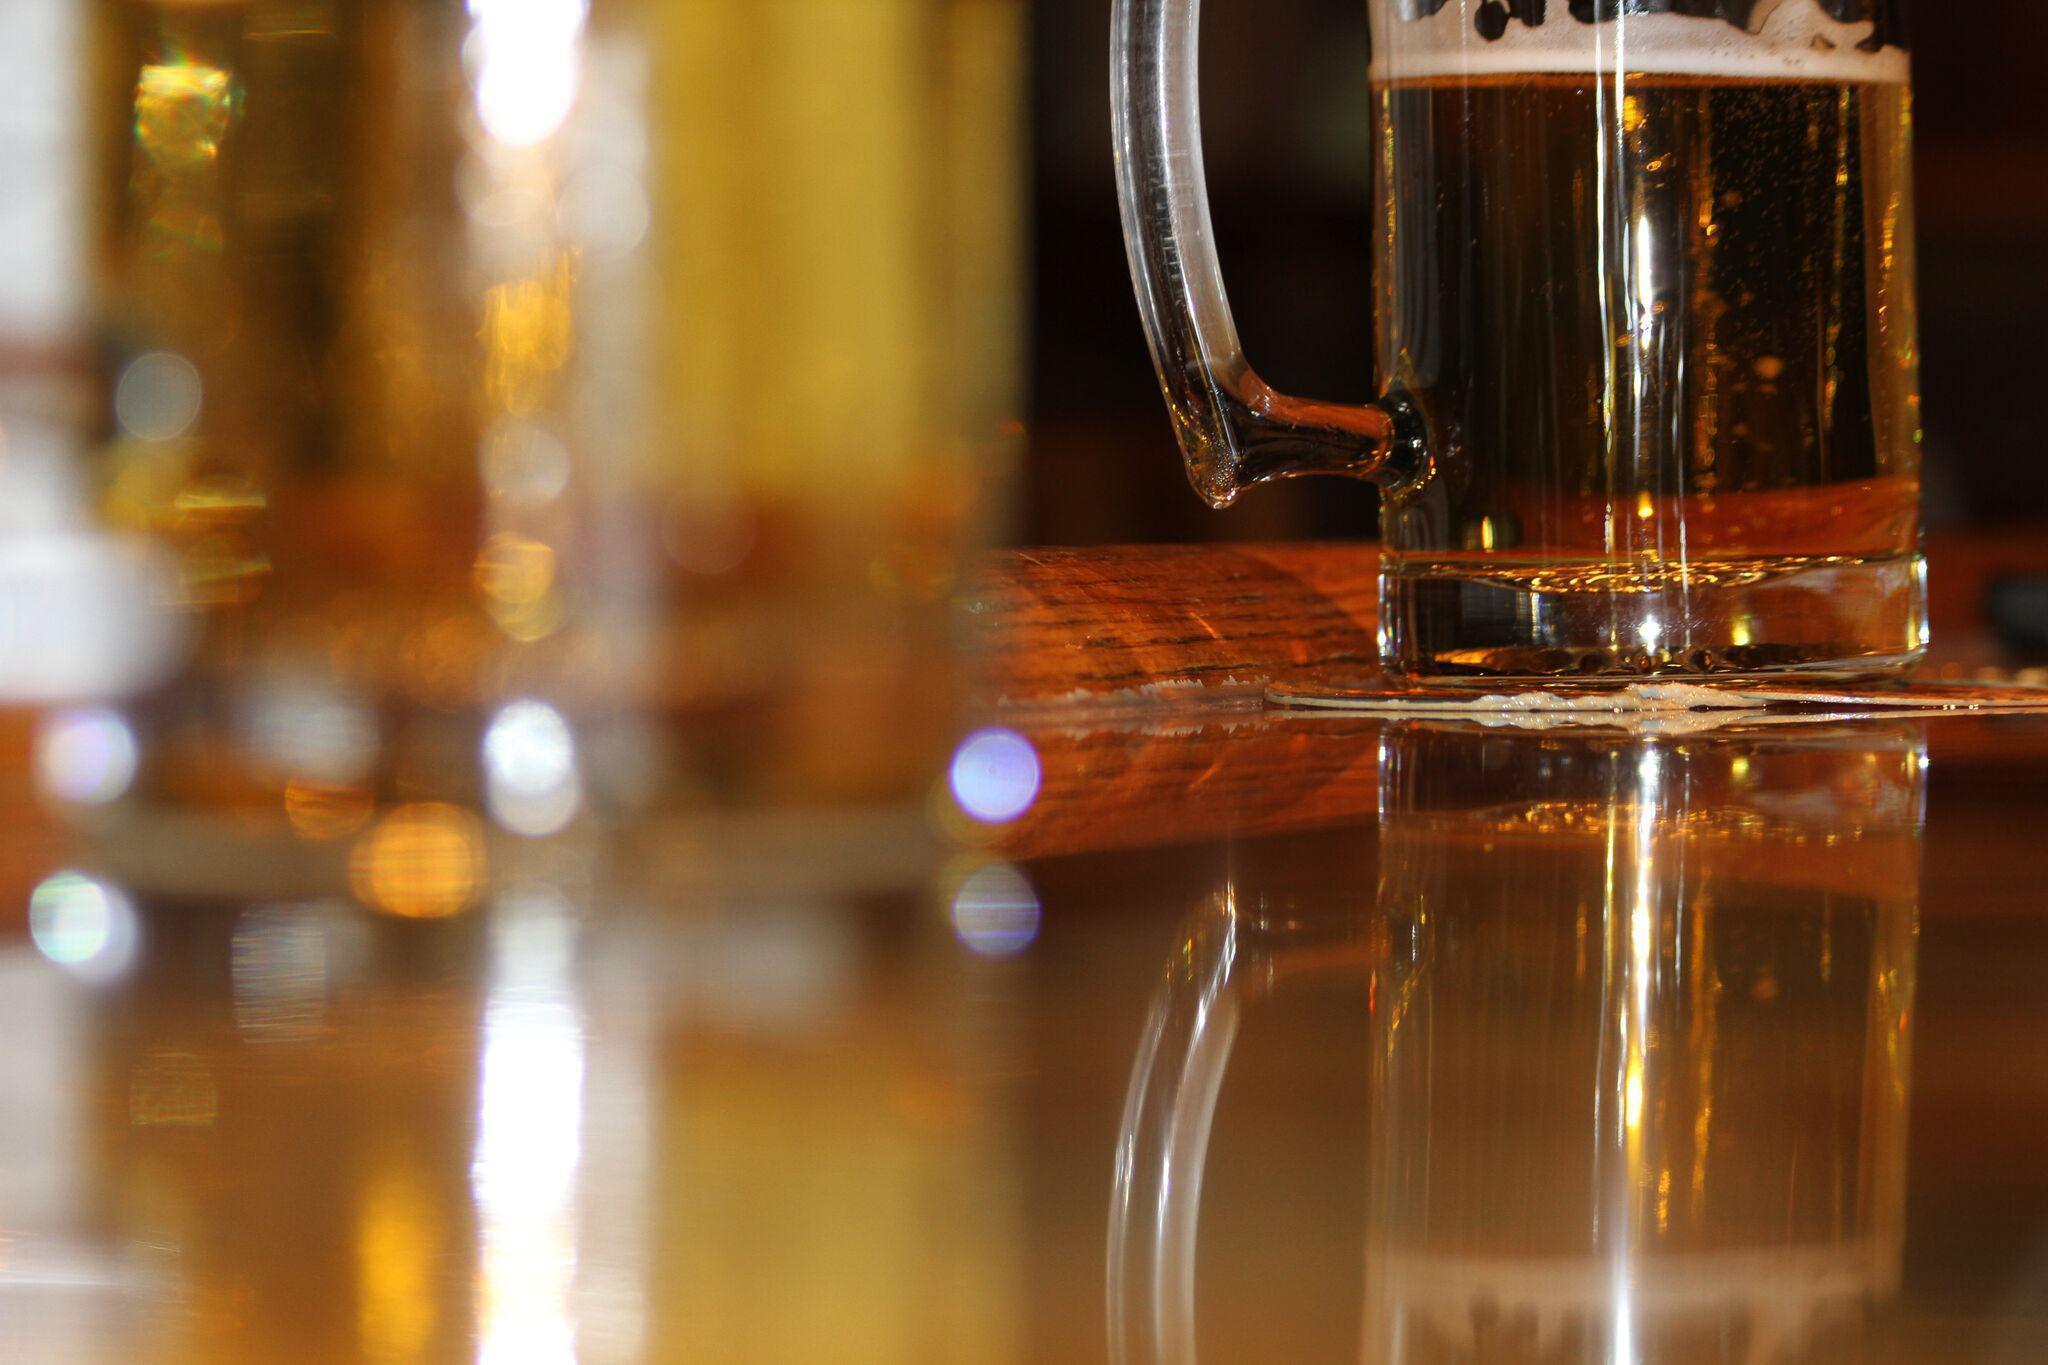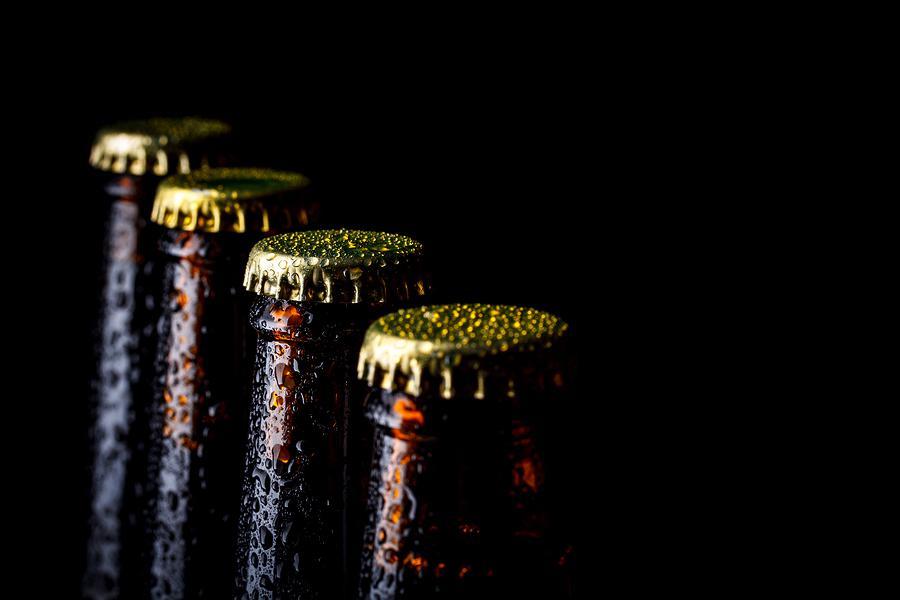The first image is the image on the left, the second image is the image on the right. Given the left and right images, does the statement "An image shows the neck of a green bottle." hold true? Answer yes or no. No. 